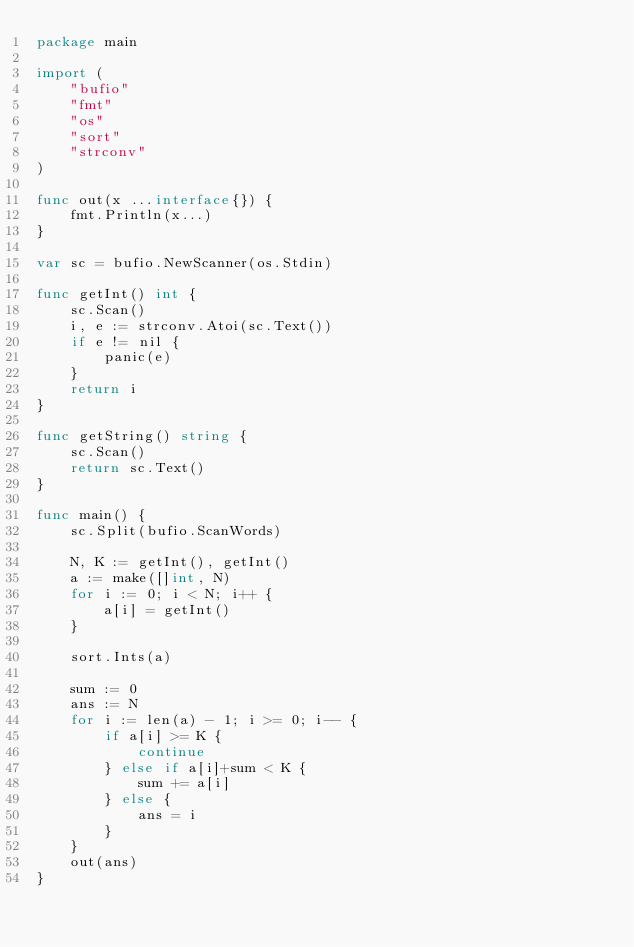<code> <loc_0><loc_0><loc_500><loc_500><_Go_>package main

import (
	"bufio"
	"fmt"
	"os"
	"sort"
	"strconv"
)

func out(x ...interface{}) {
	fmt.Println(x...)
}

var sc = bufio.NewScanner(os.Stdin)

func getInt() int {
	sc.Scan()
	i, e := strconv.Atoi(sc.Text())
	if e != nil {
		panic(e)
	}
	return i
}

func getString() string {
	sc.Scan()
	return sc.Text()
}

func main() {
	sc.Split(bufio.ScanWords)

	N, K := getInt(), getInt()
	a := make([]int, N)
	for i := 0; i < N; i++ {
		a[i] = getInt()
	}

	sort.Ints(a)

	sum := 0
	ans := N
	for i := len(a) - 1; i >= 0; i-- {
		if a[i] >= K {
			continue
		} else if a[i]+sum < K {
			sum += a[i]
		} else {
			ans = i
		}
	}
	out(ans)
}
</code> 